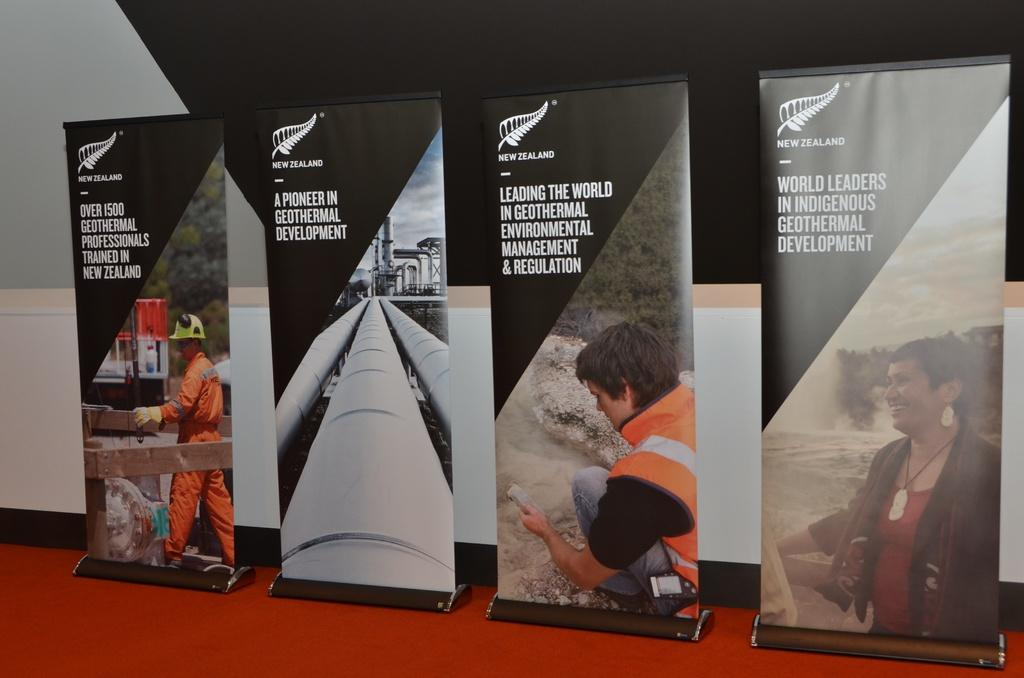<image>
Present a compact description of the photo's key features. Four banners next to one another with one saying "A pioneer in Geothermal Development". 